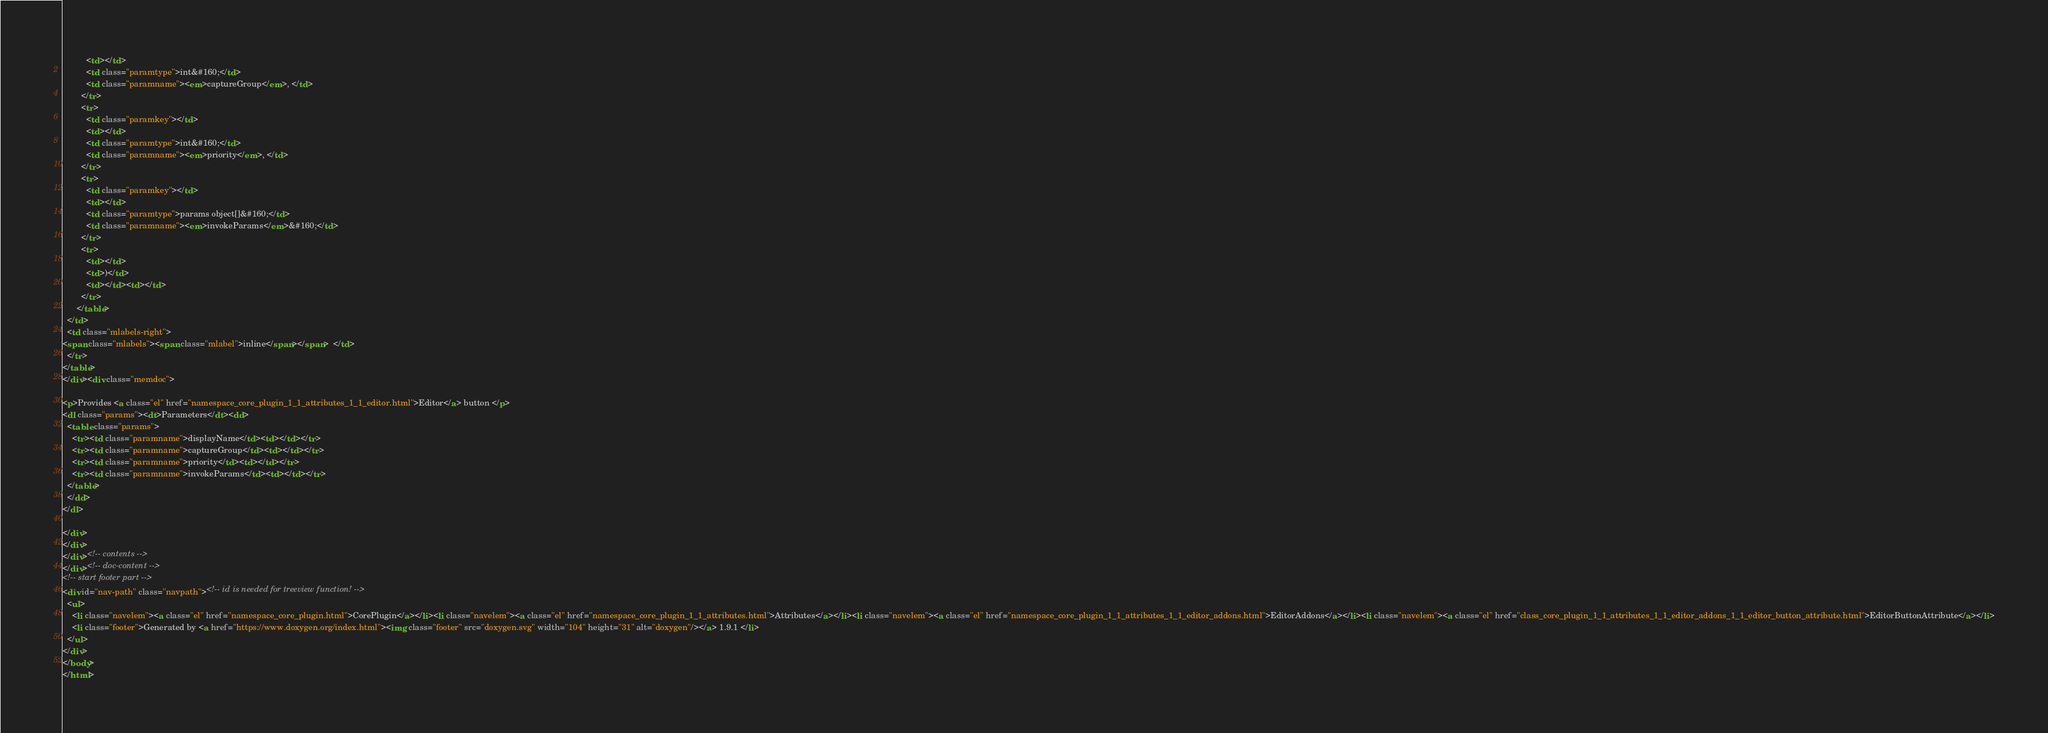<code> <loc_0><loc_0><loc_500><loc_500><_HTML_>          <td></td>
          <td class="paramtype">int&#160;</td>
          <td class="paramname"><em>captureGroup</em>, </td>
        </tr>
        <tr>
          <td class="paramkey"></td>
          <td></td>
          <td class="paramtype">int&#160;</td>
          <td class="paramname"><em>priority</em>, </td>
        </tr>
        <tr>
          <td class="paramkey"></td>
          <td></td>
          <td class="paramtype">params object[]&#160;</td>
          <td class="paramname"><em>invokeParams</em>&#160;</td>
        </tr>
        <tr>
          <td></td>
          <td>)</td>
          <td></td><td></td>
        </tr>
      </table>
  </td>
  <td class="mlabels-right">
<span class="mlabels"><span class="mlabel">inline</span></span>  </td>
  </tr>
</table>
</div><div class="memdoc">

<p>Provides <a class="el" href="namespace_core_plugin_1_1_attributes_1_1_editor.html">Editor</a> button </p>
<dl class="params"><dt>Parameters</dt><dd>
  <table class="params">
    <tr><td class="paramname">displayName</td><td></td></tr>
    <tr><td class="paramname">captureGroup</td><td></td></tr>
    <tr><td class="paramname">priority</td><td></td></tr>
    <tr><td class="paramname">invokeParams</td><td></td></tr>
  </table>
  </dd>
</dl>

</div>
</div>
</div><!-- contents -->
</div><!-- doc-content -->
<!-- start footer part -->
<div id="nav-path" class="navpath"><!-- id is needed for treeview function! -->
  <ul>
    <li class="navelem"><a class="el" href="namespace_core_plugin.html">CorePlugin</a></li><li class="navelem"><a class="el" href="namespace_core_plugin_1_1_attributes.html">Attributes</a></li><li class="navelem"><a class="el" href="namespace_core_plugin_1_1_attributes_1_1_editor_addons.html">EditorAddons</a></li><li class="navelem"><a class="el" href="class_core_plugin_1_1_attributes_1_1_editor_addons_1_1_editor_button_attribute.html">EditorButtonAttribute</a></li>
    <li class="footer">Generated by <a href="https://www.doxygen.org/index.html"><img class="footer" src="doxygen.svg" width="104" height="31" alt="doxygen"/></a> 1.9.1 </li>
  </ul>
</div>
</body>
</html>
</code> 